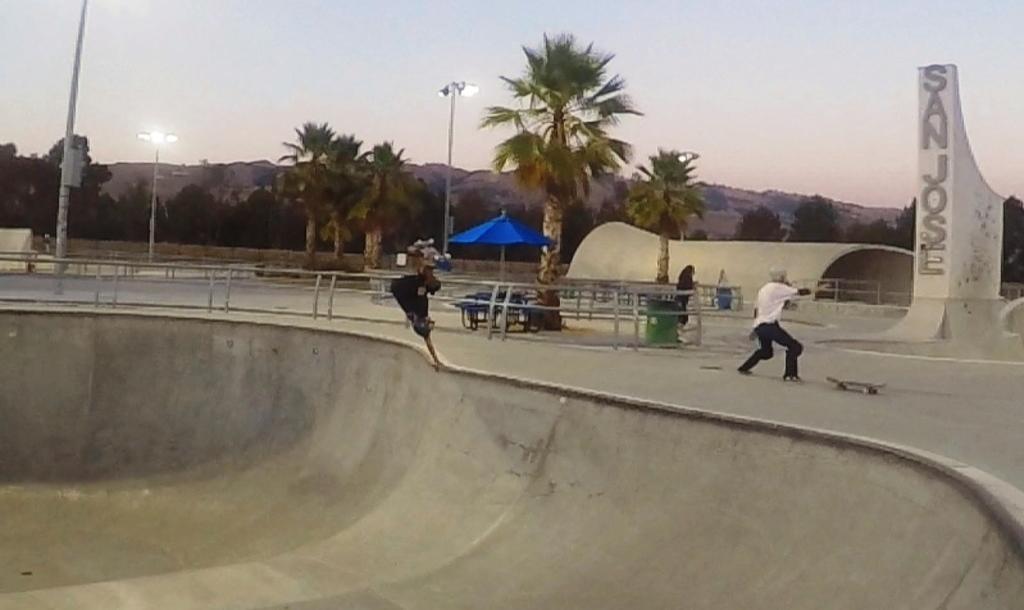Please provide a concise description of this image. In this image we can see a shed and an umbrella, there are trees, poles, lights, mountains, railings and some other objects, also we can see a statue and a person on the road. 